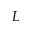<formula> <loc_0><loc_0><loc_500><loc_500>L</formula> 